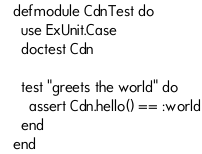<code> <loc_0><loc_0><loc_500><loc_500><_Elixir_>defmodule CdnTest do
  use ExUnit.Case
  doctest Cdn

  test "greets the world" do
    assert Cdn.hello() == :world
  end
end
</code> 